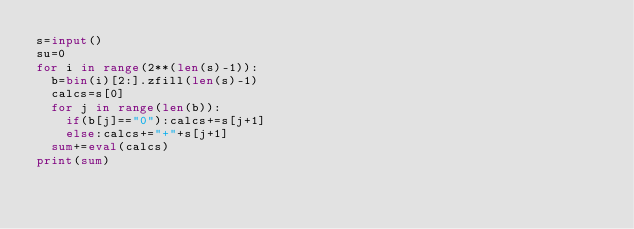<code> <loc_0><loc_0><loc_500><loc_500><_Python_>s=input()
su=0
for i in range(2**(len(s)-1)):
  b=bin(i)[2:].zfill(len(s)-1)
  calcs=s[0]
  for j in range(len(b)):
    if(b[j]=="0"):calcs+=s[j+1]
    else:calcs+="+"+s[j+1]
  sum+=eval(calcs)
print(sum)</code> 